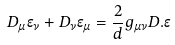Convert formula to latex. <formula><loc_0><loc_0><loc_500><loc_500>D _ { \mu } \epsilon _ { \nu } + D _ { \nu } \epsilon _ { \mu } = \frac { 2 } { d } g _ { \mu \nu } D . \epsilon</formula> 